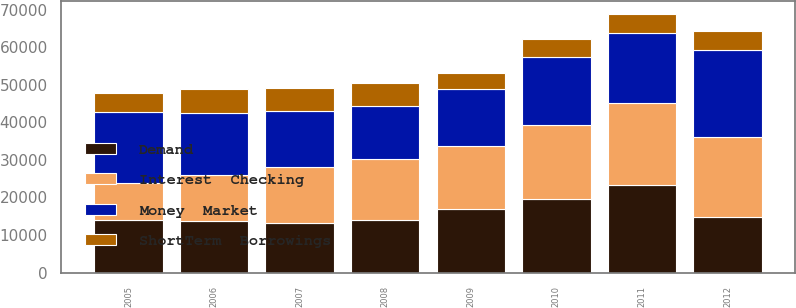<chart> <loc_0><loc_0><loc_500><loc_500><stacked_bar_chart><ecel><fcel>2012<fcel>2011<fcel>2010<fcel>2009<fcel>2008<fcel>2007<fcel>2006<fcel>2005<nl><fcel>Demand<fcel>14820<fcel>23389<fcel>19669<fcel>16862<fcel>14017<fcel>13261<fcel>13741<fcel>13868<nl><fcel>Money  Market<fcel>23096<fcel>18707<fcel>18218<fcel>15070<fcel>14191<fcel>14820<fcel>16650<fcel>18884<nl><fcel>Interest  Checking<fcel>21393<fcel>21652<fcel>19612<fcel>16875<fcel>16192<fcel>14836<fcel>12189<fcel>10007<nl><fcel>ShortTerm  Borrowings<fcel>4903<fcel>5154<fcel>4808<fcel>4320<fcel>6127<fcel>6308<fcel>6366<fcel>5170<nl></chart> 